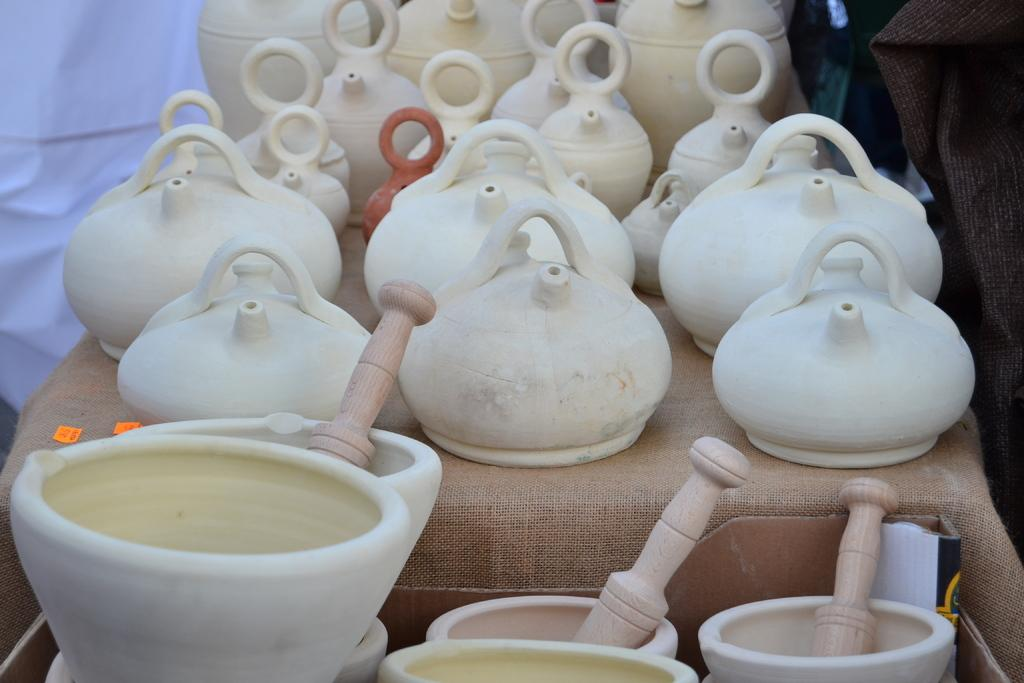What type of kitchen tools can be seen in the image? There are kettles and mortar pestles in the image. What other items are present on the table? Wooden sticks are also present on the table. Where are the kettles, mortar pestles, and wooden sticks located? They are placed on a table in the image. What can be seen in the background of the image? Clothes are visible in the background. What type of silk fabric is draped over the kettles in the image? There is no silk fabric present in the image; it only features kettles, mortar pestles, wooden sticks, and clothes in the background. 